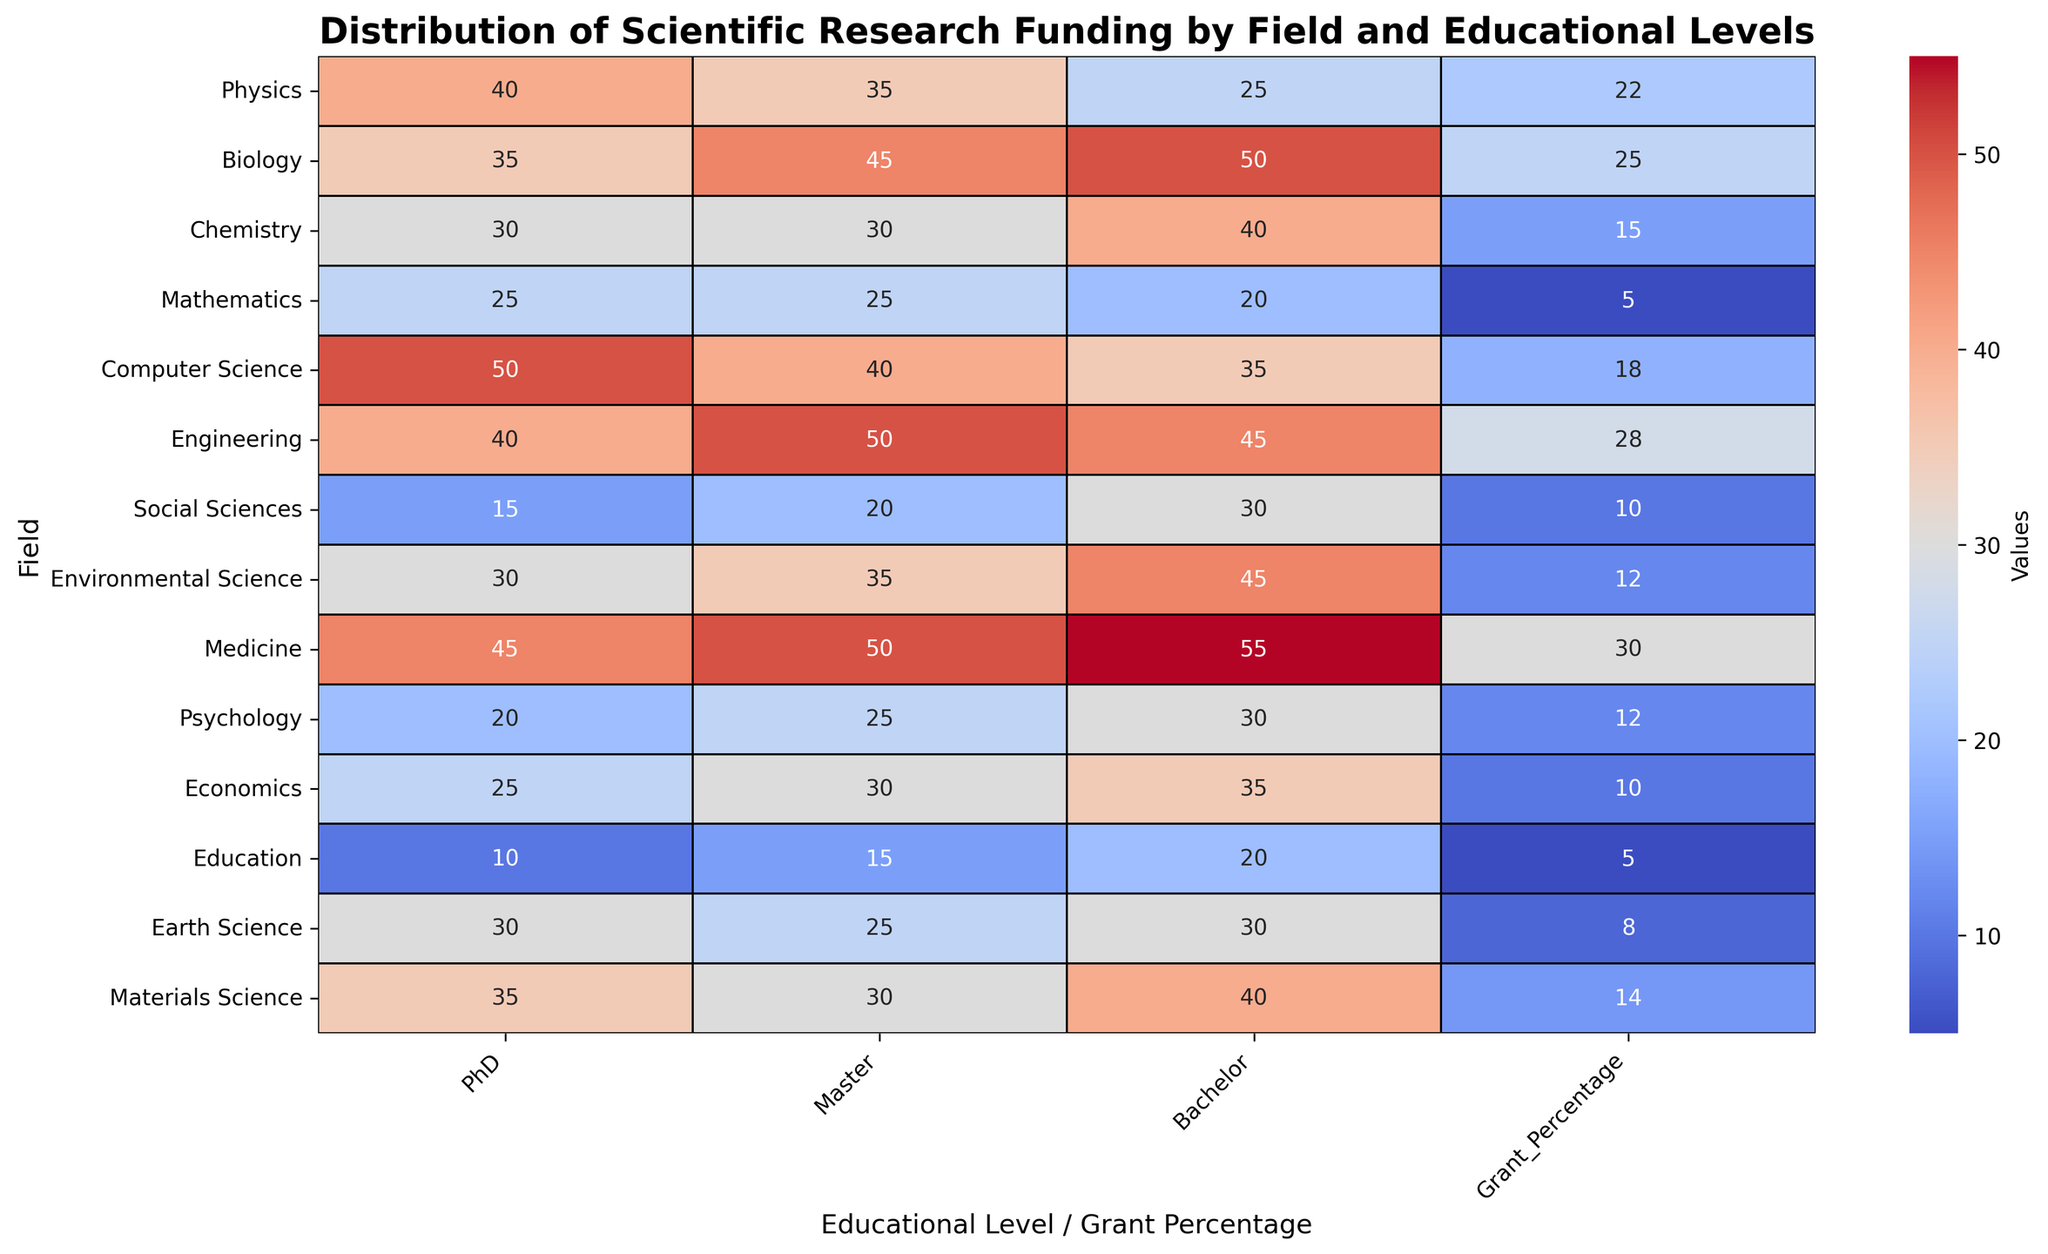What field has the highest percentage of funding grants? Look for the highest number in the "Grant_Percentage" column. Medicine has the highest percentage at 30%.
Answer: Medicine Which educational level has the largest number of students in Computer Science? Compare the values in the "PhD", "Master", and "Bachelor" columns for Computer Science. The highest number is 50, corresponding to PhD.
Answer: PhD What is the difference in the percentage of funding grants between Engineering and Chemistry? Subtract the Grant_Percentage for Chemistry from that of Engineering: 28 - 15 = 13.
Answer: 13 How does the number of PhDs in Biology compare to those in Psychology? Compare the values in the "PhD" column for Biology and Psychology. Biology has 35 PhD holders, while Psychology has 20.
Answer: Biology has more PhDs What is the average percentage of funding grants across all fields? Sum all values in the "Grant_Percentage" column and divide by the number of fields: (22 + 25 + 15 + 5 + 18 + 28 + 10 + 12 + 30 + 12 + 10 + 5 + 8 + 14) / 14 = 14.
Answer: 14 Which field has the largest total number of students when summing across all educational levels? Sum the values of PhD, Master, and Bachelor for each field and compare. Medicine: 45 + 50 + 55 = 150, which is the largest total.
Answer: Medicine How does the grant percentage for Social Sciences compare visually with that of Medicine? Visually inspect the color intensity in the "Grant_Percentage" column. Medicine's cell is darker (indicating a higher value), while Social Sciences are lighter.
Answer: Medicine has a higher percentage What is the proportion of Master to PhD students in Engineering? Calculate the ratio of Master to PhD students for Engineering: 50 / 40 = 1.25.
Answer: 1.25 Which fields have more Master students than Bachelor students? Compare the "Master" and "Bachelor" columns for all fields. Biology, Mathematics, Engineering, and Medicine have more Master students.
Answer: Biology, Mathematics, Engineering, Medicine What is the sum of the Grant_Percentage for the fields with fewer than 30% PhDs? Only Social Sciences, Psychology, Economics, and Education have fewer than 30% PhDs. Sum their Grant_Percentage: 10 + 12 + 10 + 5 = 37.
Answer: 37 